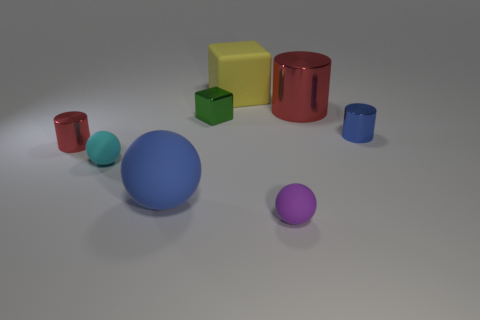What color is the cube that is made of the same material as the big blue ball?
Keep it short and to the point. Yellow. Are there the same number of big blocks that are left of the big red metal thing and tiny yellow blocks?
Make the answer very short. No. There is a red thing that is the same size as the yellow matte thing; what is its shape?
Offer a very short reply. Cylinder. What number of other objects are the same shape as the small purple matte object?
Offer a very short reply. 2. Do the purple ball and the red object on the left side of the big red metal object have the same size?
Ensure brevity in your answer.  Yes. How many objects are red cylinders in front of the green metal thing or green things?
Provide a short and direct response. 2. The rubber thing to the left of the big blue thing has what shape?
Your answer should be compact. Sphere. Are there an equal number of blue spheres right of the green metallic object and blue matte spheres behind the yellow block?
Your answer should be very brief. Yes. There is a big thing that is to the left of the small purple object and behind the blue metallic thing; what is its color?
Your answer should be compact. Yellow. What is the material of the blue object that is on the left side of the small rubber ball that is on the right side of the cyan sphere?
Offer a very short reply. Rubber. 